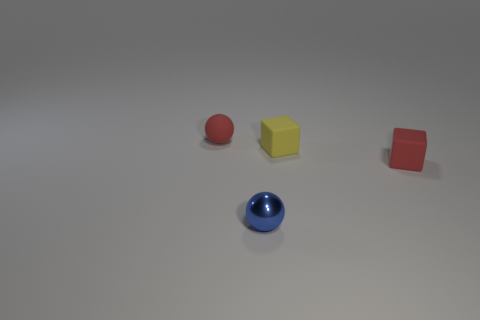Are there any metal balls that have the same size as the shiny thing? no 